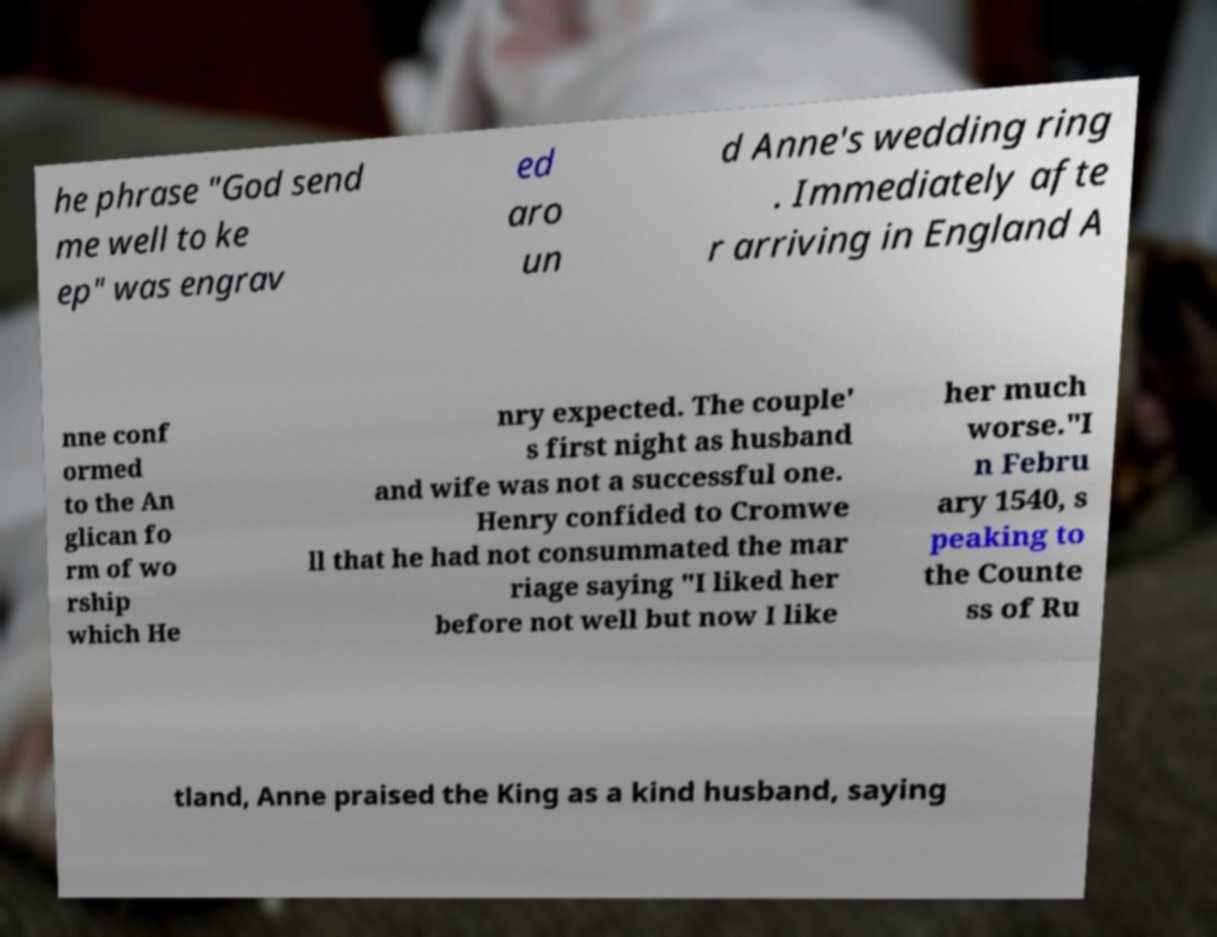There's text embedded in this image that I need extracted. Can you transcribe it verbatim? he phrase "God send me well to ke ep" was engrav ed aro un d Anne's wedding ring . Immediately afte r arriving in England A nne conf ormed to the An glican fo rm of wo rship which He nry expected. The couple' s first night as husband and wife was not a successful one. Henry confided to Cromwe ll that he had not consummated the mar riage saying "I liked her before not well but now I like her much worse."I n Febru ary 1540, s peaking to the Counte ss of Ru tland, Anne praised the King as a kind husband, saying 